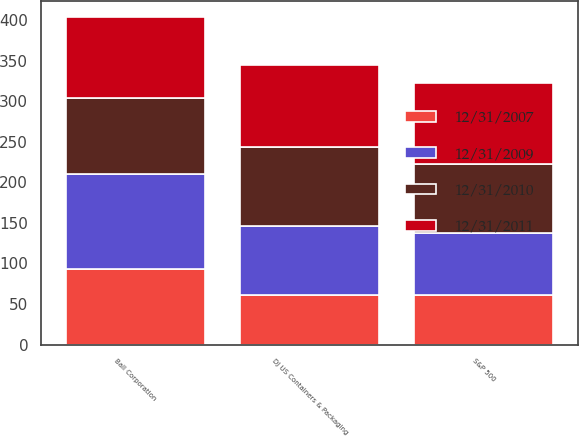Convert chart to OTSL. <chart><loc_0><loc_0><loc_500><loc_500><stacked_bar_chart><ecel><fcel>Ball Corporation<fcel>DJ US Containers & Packaging<fcel>S&P 500<nl><fcel>12/31/2011<fcel>100<fcel>100<fcel>100<nl><fcel>12/31/2007<fcel>93.28<fcel>61.55<fcel>61.51<nl><fcel>12/31/2009<fcel>117.01<fcel>84.76<fcel>75.94<nl><fcel>12/31/2010<fcel>93.28<fcel>97.78<fcel>85.65<nl></chart> 